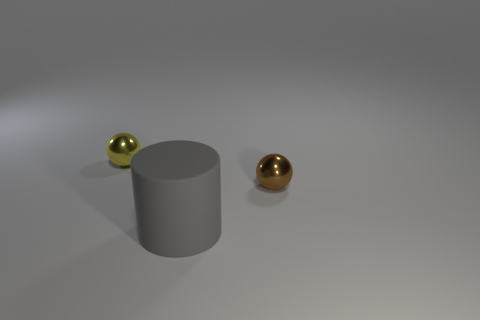Add 3 big cylinders. How many objects exist? 6 Subtract all cylinders. How many objects are left? 2 Add 1 shiny spheres. How many shiny spheres are left? 3 Add 2 cyan matte things. How many cyan matte things exist? 2 Subtract 1 gray cylinders. How many objects are left? 2 Subtract all gray matte things. Subtract all small objects. How many objects are left? 0 